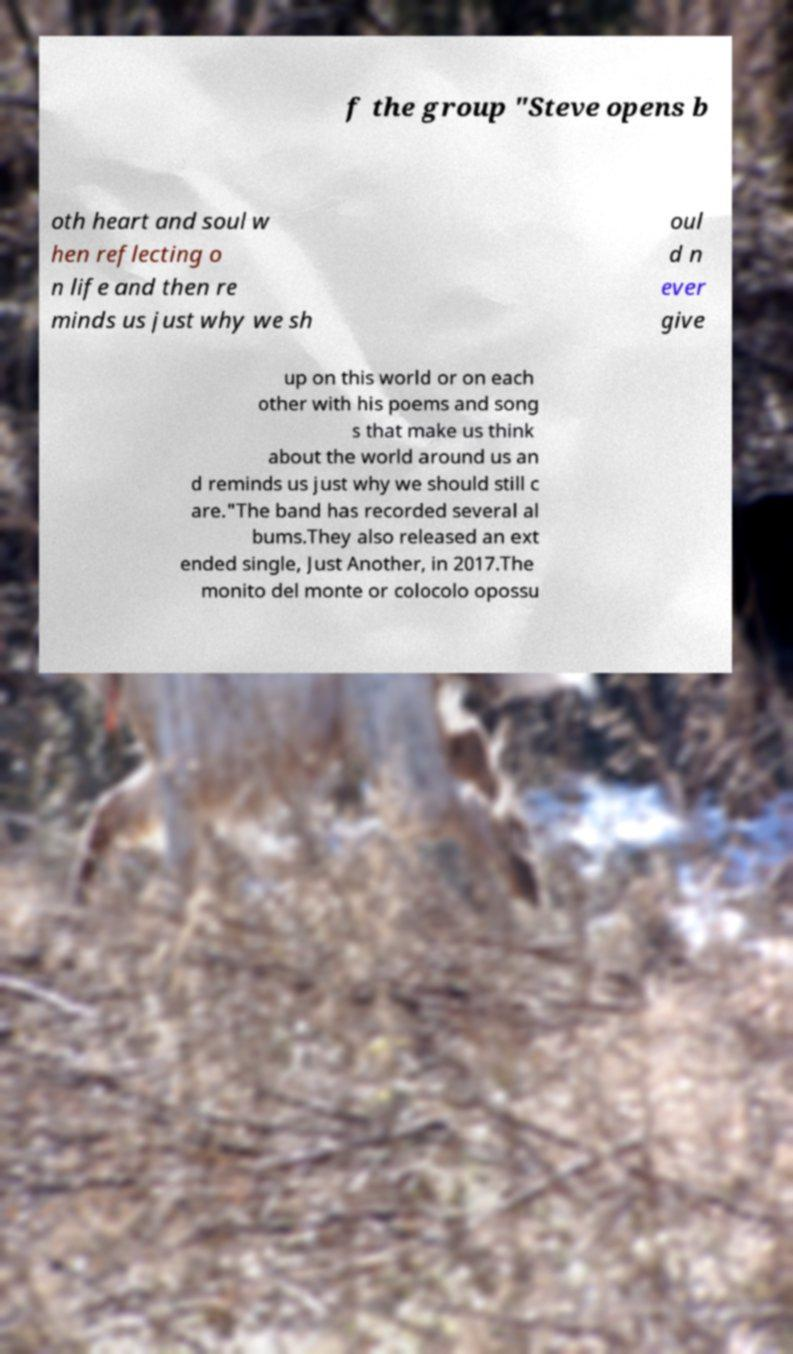Can you accurately transcribe the text from the provided image for me? f the group "Steve opens b oth heart and soul w hen reflecting o n life and then re minds us just why we sh oul d n ever give up on this world or on each other with his poems and song s that make us think about the world around us an d reminds us just why we should still c are."The band has recorded several al bums.They also released an ext ended single, Just Another, in 2017.The monito del monte or colocolo opossu 